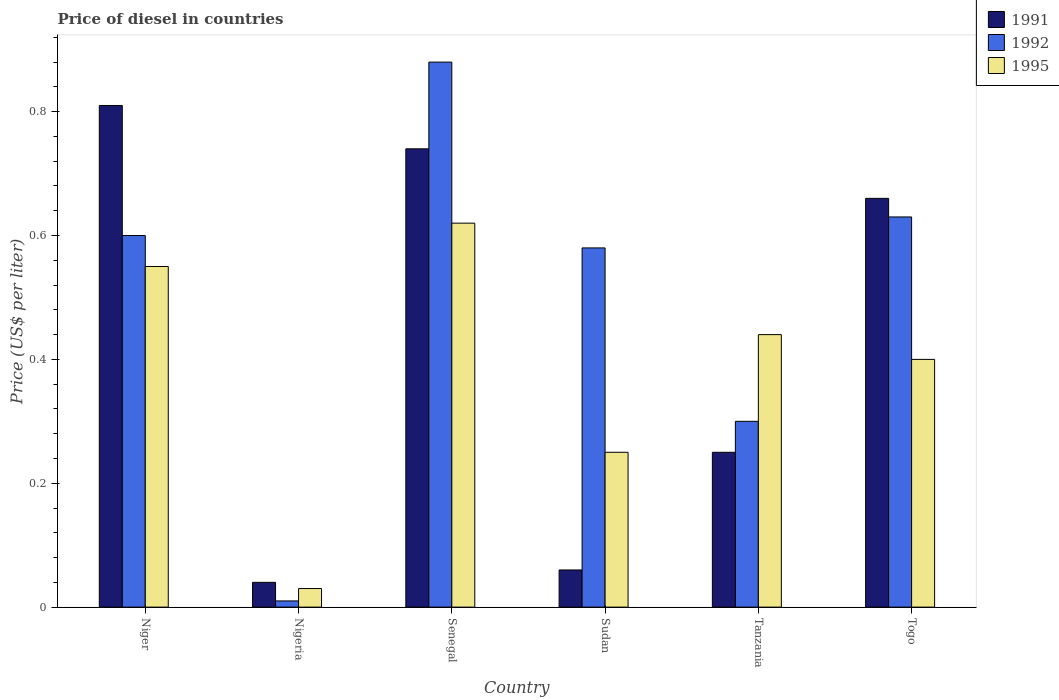How many groups of bars are there?
Ensure brevity in your answer.  6. Are the number of bars per tick equal to the number of legend labels?
Make the answer very short. Yes. How many bars are there on the 1st tick from the left?
Offer a terse response. 3. What is the label of the 1st group of bars from the left?
Your response must be concise. Niger. What is the price of diesel in 1991 in Niger?
Keep it short and to the point. 0.81. Across all countries, what is the maximum price of diesel in 1992?
Your answer should be compact. 0.88. In which country was the price of diesel in 1992 maximum?
Your response must be concise. Senegal. In which country was the price of diesel in 1995 minimum?
Offer a terse response. Nigeria. What is the total price of diesel in 1995 in the graph?
Ensure brevity in your answer.  2.29. What is the difference between the price of diesel in 1991 in Senegal and that in Tanzania?
Make the answer very short. 0.49. What is the difference between the price of diesel in 1992 in Togo and the price of diesel in 1995 in Nigeria?
Offer a terse response. 0.6. What is the average price of diesel in 1992 per country?
Keep it short and to the point. 0.5. What is the difference between the price of diesel of/in 1995 and price of diesel of/in 1992 in Togo?
Provide a short and direct response. -0.23. What is the ratio of the price of diesel in 1992 in Niger to that in Sudan?
Your response must be concise. 1.03. Is the price of diesel in 1991 in Niger less than that in Sudan?
Your answer should be very brief. No. What is the difference between the highest and the second highest price of diesel in 1992?
Offer a very short reply. 0.25. What is the difference between the highest and the lowest price of diesel in 1995?
Your response must be concise. 0.59. In how many countries, is the price of diesel in 1995 greater than the average price of diesel in 1995 taken over all countries?
Offer a very short reply. 4. Is the sum of the price of diesel in 1992 in Nigeria and Togo greater than the maximum price of diesel in 1995 across all countries?
Offer a terse response. Yes. What does the 1st bar from the left in Togo represents?
Offer a very short reply. 1991. How many countries are there in the graph?
Your response must be concise. 6. Are the values on the major ticks of Y-axis written in scientific E-notation?
Ensure brevity in your answer.  No. Where does the legend appear in the graph?
Your answer should be very brief. Top right. How many legend labels are there?
Your answer should be very brief. 3. What is the title of the graph?
Your answer should be very brief. Price of diesel in countries. Does "1993" appear as one of the legend labels in the graph?
Your response must be concise. No. What is the label or title of the Y-axis?
Offer a terse response. Price (US$ per liter). What is the Price (US$ per liter) in 1991 in Niger?
Your answer should be very brief. 0.81. What is the Price (US$ per liter) of 1995 in Niger?
Your answer should be very brief. 0.55. What is the Price (US$ per liter) of 1991 in Nigeria?
Your answer should be compact. 0.04. What is the Price (US$ per liter) of 1992 in Nigeria?
Your response must be concise. 0.01. What is the Price (US$ per liter) in 1991 in Senegal?
Provide a short and direct response. 0.74. What is the Price (US$ per liter) of 1992 in Senegal?
Your response must be concise. 0.88. What is the Price (US$ per liter) in 1995 in Senegal?
Give a very brief answer. 0.62. What is the Price (US$ per liter) in 1992 in Sudan?
Your response must be concise. 0.58. What is the Price (US$ per liter) of 1991 in Tanzania?
Make the answer very short. 0.25. What is the Price (US$ per liter) in 1995 in Tanzania?
Provide a succinct answer. 0.44. What is the Price (US$ per liter) in 1991 in Togo?
Your response must be concise. 0.66. What is the Price (US$ per liter) in 1992 in Togo?
Your answer should be very brief. 0.63. What is the Price (US$ per liter) in 1995 in Togo?
Provide a succinct answer. 0.4. Across all countries, what is the maximum Price (US$ per liter) of 1991?
Your answer should be very brief. 0.81. Across all countries, what is the maximum Price (US$ per liter) of 1995?
Your answer should be compact. 0.62. Across all countries, what is the minimum Price (US$ per liter) in 1991?
Your answer should be very brief. 0.04. Across all countries, what is the minimum Price (US$ per liter) of 1992?
Your answer should be compact. 0.01. What is the total Price (US$ per liter) in 1991 in the graph?
Ensure brevity in your answer.  2.56. What is the total Price (US$ per liter) in 1992 in the graph?
Your answer should be very brief. 3. What is the total Price (US$ per liter) in 1995 in the graph?
Offer a very short reply. 2.29. What is the difference between the Price (US$ per liter) in 1991 in Niger and that in Nigeria?
Make the answer very short. 0.77. What is the difference between the Price (US$ per liter) in 1992 in Niger and that in Nigeria?
Offer a terse response. 0.59. What is the difference between the Price (US$ per liter) of 1995 in Niger and that in Nigeria?
Provide a short and direct response. 0.52. What is the difference between the Price (US$ per liter) of 1991 in Niger and that in Senegal?
Provide a succinct answer. 0.07. What is the difference between the Price (US$ per liter) in 1992 in Niger and that in Senegal?
Your answer should be compact. -0.28. What is the difference between the Price (US$ per liter) of 1995 in Niger and that in Senegal?
Your response must be concise. -0.07. What is the difference between the Price (US$ per liter) of 1991 in Niger and that in Tanzania?
Your answer should be very brief. 0.56. What is the difference between the Price (US$ per liter) of 1992 in Niger and that in Tanzania?
Keep it short and to the point. 0.3. What is the difference between the Price (US$ per liter) in 1995 in Niger and that in Tanzania?
Your answer should be compact. 0.11. What is the difference between the Price (US$ per liter) in 1991 in Niger and that in Togo?
Offer a very short reply. 0.15. What is the difference between the Price (US$ per liter) of 1992 in Niger and that in Togo?
Your answer should be compact. -0.03. What is the difference between the Price (US$ per liter) in 1995 in Niger and that in Togo?
Provide a short and direct response. 0.15. What is the difference between the Price (US$ per liter) of 1991 in Nigeria and that in Senegal?
Keep it short and to the point. -0.7. What is the difference between the Price (US$ per liter) in 1992 in Nigeria and that in Senegal?
Make the answer very short. -0.87. What is the difference between the Price (US$ per liter) in 1995 in Nigeria and that in Senegal?
Keep it short and to the point. -0.59. What is the difference between the Price (US$ per liter) in 1991 in Nigeria and that in Sudan?
Provide a succinct answer. -0.02. What is the difference between the Price (US$ per liter) of 1992 in Nigeria and that in Sudan?
Keep it short and to the point. -0.57. What is the difference between the Price (US$ per liter) of 1995 in Nigeria and that in Sudan?
Your answer should be very brief. -0.22. What is the difference between the Price (US$ per liter) in 1991 in Nigeria and that in Tanzania?
Offer a terse response. -0.21. What is the difference between the Price (US$ per liter) of 1992 in Nigeria and that in Tanzania?
Make the answer very short. -0.29. What is the difference between the Price (US$ per liter) of 1995 in Nigeria and that in Tanzania?
Give a very brief answer. -0.41. What is the difference between the Price (US$ per liter) in 1991 in Nigeria and that in Togo?
Offer a very short reply. -0.62. What is the difference between the Price (US$ per liter) in 1992 in Nigeria and that in Togo?
Offer a terse response. -0.62. What is the difference between the Price (US$ per liter) in 1995 in Nigeria and that in Togo?
Offer a terse response. -0.37. What is the difference between the Price (US$ per liter) of 1991 in Senegal and that in Sudan?
Make the answer very short. 0.68. What is the difference between the Price (US$ per liter) in 1995 in Senegal and that in Sudan?
Ensure brevity in your answer.  0.37. What is the difference between the Price (US$ per liter) in 1991 in Senegal and that in Tanzania?
Give a very brief answer. 0.49. What is the difference between the Price (US$ per liter) of 1992 in Senegal and that in Tanzania?
Give a very brief answer. 0.58. What is the difference between the Price (US$ per liter) of 1995 in Senegal and that in Tanzania?
Ensure brevity in your answer.  0.18. What is the difference between the Price (US$ per liter) of 1995 in Senegal and that in Togo?
Provide a short and direct response. 0.22. What is the difference between the Price (US$ per liter) in 1991 in Sudan and that in Tanzania?
Your answer should be compact. -0.19. What is the difference between the Price (US$ per liter) of 1992 in Sudan and that in Tanzania?
Give a very brief answer. 0.28. What is the difference between the Price (US$ per liter) in 1995 in Sudan and that in Tanzania?
Your answer should be very brief. -0.19. What is the difference between the Price (US$ per liter) of 1991 in Sudan and that in Togo?
Provide a succinct answer. -0.6. What is the difference between the Price (US$ per liter) in 1991 in Tanzania and that in Togo?
Make the answer very short. -0.41. What is the difference between the Price (US$ per liter) in 1992 in Tanzania and that in Togo?
Give a very brief answer. -0.33. What is the difference between the Price (US$ per liter) of 1995 in Tanzania and that in Togo?
Provide a short and direct response. 0.04. What is the difference between the Price (US$ per liter) in 1991 in Niger and the Price (US$ per liter) in 1995 in Nigeria?
Provide a succinct answer. 0.78. What is the difference between the Price (US$ per liter) in 1992 in Niger and the Price (US$ per liter) in 1995 in Nigeria?
Keep it short and to the point. 0.57. What is the difference between the Price (US$ per liter) of 1991 in Niger and the Price (US$ per liter) of 1992 in Senegal?
Provide a succinct answer. -0.07. What is the difference between the Price (US$ per liter) of 1991 in Niger and the Price (US$ per liter) of 1995 in Senegal?
Your answer should be compact. 0.19. What is the difference between the Price (US$ per liter) of 1992 in Niger and the Price (US$ per liter) of 1995 in Senegal?
Give a very brief answer. -0.02. What is the difference between the Price (US$ per liter) of 1991 in Niger and the Price (US$ per liter) of 1992 in Sudan?
Offer a very short reply. 0.23. What is the difference between the Price (US$ per liter) in 1991 in Niger and the Price (US$ per liter) in 1995 in Sudan?
Keep it short and to the point. 0.56. What is the difference between the Price (US$ per liter) in 1991 in Niger and the Price (US$ per liter) in 1992 in Tanzania?
Give a very brief answer. 0.51. What is the difference between the Price (US$ per liter) of 1991 in Niger and the Price (US$ per liter) of 1995 in Tanzania?
Your answer should be compact. 0.37. What is the difference between the Price (US$ per liter) of 1992 in Niger and the Price (US$ per liter) of 1995 in Tanzania?
Ensure brevity in your answer.  0.16. What is the difference between the Price (US$ per liter) of 1991 in Niger and the Price (US$ per liter) of 1992 in Togo?
Your answer should be compact. 0.18. What is the difference between the Price (US$ per liter) in 1991 in Niger and the Price (US$ per liter) in 1995 in Togo?
Ensure brevity in your answer.  0.41. What is the difference between the Price (US$ per liter) in 1991 in Nigeria and the Price (US$ per liter) in 1992 in Senegal?
Your response must be concise. -0.84. What is the difference between the Price (US$ per liter) of 1991 in Nigeria and the Price (US$ per liter) of 1995 in Senegal?
Provide a succinct answer. -0.58. What is the difference between the Price (US$ per liter) of 1992 in Nigeria and the Price (US$ per liter) of 1995 in Senegal?
Make the answer very short. -0.61. What is the difference between the Price (US$ per liter) of 1991 in Nigeria and the Price (US$ per liter) of 1992 in Sudan?
Keep it short and to the point. -0.54. What is the difference between the Price (US$ per liter) in 1991 in Nigeria and the Price (US$ per liter) in 1995 in Sudan?
Offer a terse response. -0.21. What is the difference between the Price (US$ per liter) of 1992 in Nigeria and the Price (US$ per liter) of 1995 in Sudan?
Your answer should be very brief. -0.24. What is the difference between the Price (US$ per liter) in 1991 in Nigeria and the Price (US$ per liter) in 1992 in Tanzania?
Your answer should be very brief. -0.26. What is the difference between the Price (US$ per liter) in 1992 in Nigeria and the Price (US$ per liter) in 1995 in Tanzania?
Provide a short and direct response. -0.43. What is the difference between the Price (US$ per liter) of 1991 in Nigeria and the Price (US$ per liter) of 1992 in Togo?
Offer a very short reply. -0.59. What is the difference between the Price (US$ per liter) in 1991 in Nigeria and the Price (US$ per liter) in 1995 in Togo?
Give a very brief answer. -0.36. What is the difference between the Price (US$ per liter) in 1992 in Nigeria and the Price (US$ per liter) in 1995 in Togo?
Ensure brevity in your answer.  -0.39. What is the difference between the Price (US$ per liter) in 1991 in Senegal and the Price (US$ per liter) in 1992 in Sudan?
Give a very brief answer. 0.16. What is the difference between the Price (US$ per liter) in 1991 in Senegal and the Price (US$ per liter) in 1995 in Sudan?
Offer a very short reply. 0.49. What is the difference between the Price (US$ per liter) of 1992 in Senegal and the Price (US$ per liter) of 1995 in Sudan?
Offer a terse response. 0.63. What is the difference between the Price (US$ per liter) of 1991 in Senegal and the Price (US$ per liter) of 1992 in Tanzania?
Provide a succinct answer. 0.44. What is the difference between the Price (US$ per liter) of 1992 in Senegal and the Price (US$ per liter) of 1995 in Tanzania?
Make the answer very short. 0.44. What is the difference between the Price (US$ per liter) of 1991 in Senegal and the Price (US$ per liter) of 1992 in Togo?
Provide a short and direct response. 0.11. What is the difference between the Price (US$ per liter) in 1991 in Senegal and the Price (US$ per liter) in 1995 in Togo?
Provide a succinct answer. 0.34. What is the difference between the Price (US$ per liter) in 1992 in Senegal and the Price (US$ per liter) in 1995 in Togo?
Offer a terse response. 0.48. What is the difference between the Price (US$ per liter) of 1991 in Sudan and the Price (US$ per liter) of 1992 in Tanzania?
Your response must be concise. -0.24. What is the difference between the Price (US$ per liter) of 1991 in Sudan and the Price (US$ per liter) of 1995 in Tanzania?
Provide a short and direct response. -0.38. What is the difference between the Price (US$ per liter) in 1992 in Sudan and the Price (US$ per liter) in 1995 in Tanzania?
Give a very brief answer. 0.14. What is the difference between the Price (US$ per liter) of 1991 in Sudan and the Price (US$ per liter) of 1992 in Togo?
Offer a terse response. -0.57. What is the difference between the Price (US$ per liter) in 1991 in Sudan and the Price (US$ per liter) in 1995 in Togo?
Give a very brief answer. -0.34. What is the difference between the Price (US$ per liter) in 1992 in Sudan and the Price (US$ per liter) in 1995 in Togo?
Your answer should be very brief. 0.18. What is the difference between the Price (US$ per liter) in 1991 in Tanzania and the Price (US$ per liter) in 1992 in Togo?
Offer a terse response. -0.38. What is the average Price (US$ per liter) of 1991 per country?
Provide a short and direct response. 0.43. What is the average Price (US$ per liter) of 1992 per country?
Give a very brief answer. 0.5. What is the average Price (US$ per liter) of 1995 per country?
Offer a very short reply. 0.38. What is the difference between the Price (US$ per liter) in 1991 and Price (US$ per liter) in 1992 in Niger?
Make the answer very short. 0.21. What is the difference between the Price (US$ per liter) in 1991 and Price (US$ per liter) in 1995 in Niger?
Provide a succinct answer. 0.26. What is the difference between the Price (US$ per liter) in 1991 and Price (US$ per liter) in 1992 in Nigeria?
Provide a short and direct response. 0.03. What is the difference between the Price (US$ per liter) of 1992 and Price (US$ per liter) of 1995 in Nigeria?
Offer a terse response. -0.02. What is the difference between the Price (US$ per liter) of 1991 and Price (US$ per liter) of 1992 in Senegal?
Offer a very short reply. -0.14. What is the difference between the Price (US$ per liter) of 1991 and Price (US$ per liter) of 1995 in Senegal?
Provide a succinct answer. 0.12. What is the difference between the Price (US$ per liter) of 1992 and Price (US$ per liter) of 1995 in Senegal?
Your answer should be compact. 0.26. What is the difference between the Price (US$ per liter) in 1991 and Price (US$ per liter) in 1992 in Sudan?
Your answer should be very brief. -0.52. What is the difference between the Price (US$ per liter) in 1991 and Price (US$ per liter) in 1995 in Sudan?
Your answer should be compact. -0.19. What is the difference between the Price (US$ per liter) in 1992 and Price (US$ per liter) in 1995 in Sudan?
Your answer should be compact. 0.33. What is the difference between the Price (US$ per liter) in 1991 and Price (US$ per liter) in 1992 in Tanzania?
Keep it short and to the point. -0.05. What is the difference between the Price (US$ per liter) in 1991 and Price (US$ per liter) in 1995 in Tanzania?
Offer a terse response. -0.19. What is the difference between the Price (US$ per liter) of 1992 and Price (US$ per liter) of 1995 in Tanzania?
Provide a short and direct response. -0.14. What is the difference between the Price (US$ per liter) in 1991 and Price (US$ per liter) in 1995 in Togo?
Offer a very short reply. 0.26. What is the difference between the Price (US$ per liter) in 1992 and Price (US$ per liter) in 1995 in Togo?
Ensure brevity in your answer.  0.23. What is the ratio of the Price (US$ per liter) of 1991 in Niger to that in Nigeria?
Make the answer very short. 20.25. What is the ratio of the Price (US$ per liter) in 1995 in Niger to that in Nigeria?
Your answer should be very brief. 18.33. What is the ratio of the Price (US$ per liter) in 1991 in Niger to that in Senegal?
Offer a very short reply. 1.09. What is the ratio of the Price (US$ per liter) in 1992 in Niger to that in Senegal?
Ensure brevity in your answer.  0.68. What is the ratio of the Price (US$ per liter) in 1995 in Niger to that in Senegal?
Provide a short and direct response. 0.89. What is the ratio of the Price (US$ per liter) in 1992 in Niger to that in Sudan?
Keep it short and to the point. 1.03. What is the ratio of the Price (US$ per liter) in 1995 in Niger to that in Sudan?
Make the answer very short. 2.2. What is the ratio of the Price (US$ per liter) in 1991 in Niger to that in Tanzania?
Keep it short and to the point. 3.24. What is the ratio of the Price (US$ per liter) in 1992 in Niger to that in Tanzania?
Provide a short and direct response. 2. What is the ratio of the Price (US$ per liter) in 1995 in Niger to that in Tanzania?
Provide a short and direct response. 1.25. What is the ratio of the Price (US$ per liter) in 1991 in Niger to that in Togo?
Offer a very short reply. 1.23. What is the ratio of the Price (US$ per liter) of 1995 in Niger to that in Togo?
Offer a terse response. 1.38. What is the ratio of the Price (US$ per liter) in 1991 in Nigeria to that in Senegal?
Your answer should be very brief. 0.05. What is the ratio of the Price (US$ per liter) in 1992 in Nigeria to that in Senegal?
Your response must be concise. 0.01. What is the ratio of the Price (US$ per liter) of 1995 in Nigeria to that in Senegal?
Ensure brevity in your answer.  0.05. What is the ratio of the Price (US$ per liter) of 1991 in Nigeria to that in Sudan?
Make the answer very short. 0.67. What is the ratio of the Price (US$ per liter) of 1992 in Nigeria to that in Sudan?
Your answer should be very brief. 0.02. What is the ratio of the Price (US$ per liter) in 1995 in Nigeria to that in Sudan?
Ensure brevity in your answer.  0.12. What is the ratio of the Price (US$ per liter) of 1991 in Nigeria to that in Tanzania?
Your answer should be very brief. 0.16. What is the ratio of the Price (US$ per liter) of 1995 in Nigeria to that in Tanzania?
Offer a terse response. 0.07. What is the ratio of the Price (US$ per liter) in 1991 in Nigeria to that in Togo?
Offer a very short reply. 0.06. What is the ratio of the Price (US$ per liter) of 1992 in Nigeria to that in Togo?
Give a very brief answer. 0.02. What is the ratio of the Price (US$ per liter) in 1995 in Nigeria to that in Togo?
Offer a very short reply. 0.07. What is the ratio of the Price (US$ per liter) of 1991 in Senegal to that in Sudan?
Make the answer very short. 12.33. What is the ratio of the Price (US$ per liter) in 1992 in Senegal to that in Sudan?
Provide a succinct answer. 1.52. What is the ratio of the Price (US$ per liter) of 1995 in Senegal to that in Sudan?
Ensure brevity in your answer.  2.48. What is the ratio of the Price (US$ per liter) in 1991 in Senegal to that in Tanzania?
Your response must be concise. 2.96. What is the ratio of the Price (US$ per liter) of 1992 in Senegal to that in Tanzania?
Provide a short and direct response. 2.93. What is the ratio of the Price (US$ per liter) in 1995 in Senegal to that in Tanzania?
Provide a succinct answer. 1.41. What is the ratio of the Price (US$ per liter) of 1991 in Senegal to that in Togo?
Your answer should be very brief. 1.12. What is the ratio of the Price (US$ per liter) of 1992 in Senegal to that in Togo?
Keep it short and to the point. 1.4. What is the ratio of the Price (US$ per liter) in 1995 in Senegal to that in Togo?
Give a very brief answer. 1.55. What is the ratio of the Price (US$ per liter) in 1991 in Sudan to that in Tanzania?
Provide a short and direct response. 0.24. What is the ratio of the Price (US$ per liter) in 1992 in Sudan to that in Tanzania?
Keep it short and to the point. 1.93. What is the ratio of the Price (US$ per liter) of 1995 in Sudan to that in Tanzania?
Offer a very short reply. 0.57. What is the ratio of the Price (US$ per liter) in 1991 in Sudan to that in Togo?
Your answer should be very brief. 0.09. What is the ratio of the Price (US$ per liter) of 1992 in Sudan to that in Togo?
Offer a terse response. 0.92. What is the ratio of the Price (US$ per liter) of 1995 in Sudan to that in Togo?
Offer a very short reply. 0.62. What is the ratio of the Price (US$ per liter) of 1991 in Tanzania to that in Togo?
Provide a succinct answer. 0.38. What is the ratio of the Price (US$ per liter) of 1992 in Tanzania to that in Togo?
Your answer should be very brief. 0.48. What is the difference between the highest and the second highest Price (US$ per liter) in 1991?
Your answer should be very brief. 0.07. What is the difference between the highest and the second highest Price (US$ per liter) of 1995?
Your response must be concise. 0.07. What is the difference between the highest and the lowest Price (US$ per liter) in 1991?
Your answer should be very brief. 0.77. What is the difference between the highest and the lowest Price (US$ per liter) in 1992?
Your response must be concise. 0.87. What is the difference between the highest and the lowest Price (US$ per liter) of 1995?
Offer a very short reply. 0.59. 